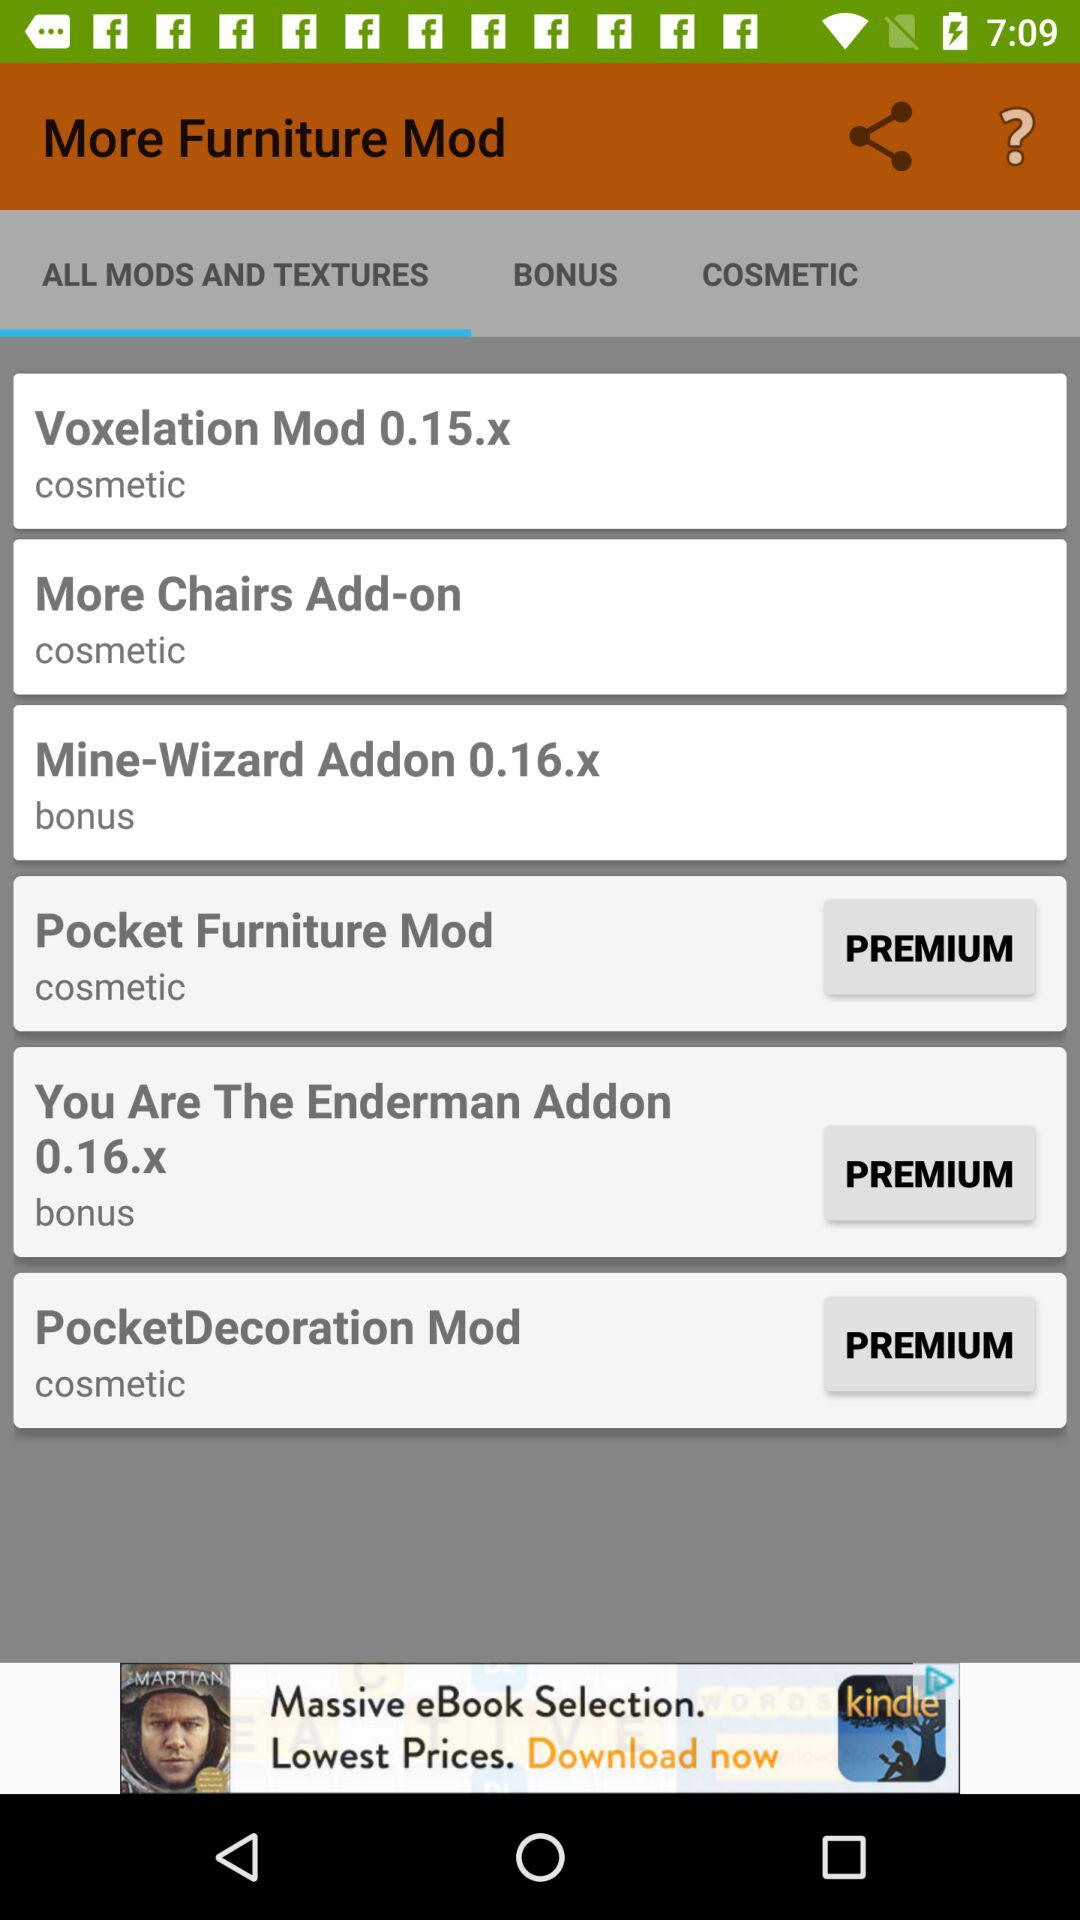What is the texture of "More Chairs Add-on"? The texture is "cosmetic". 